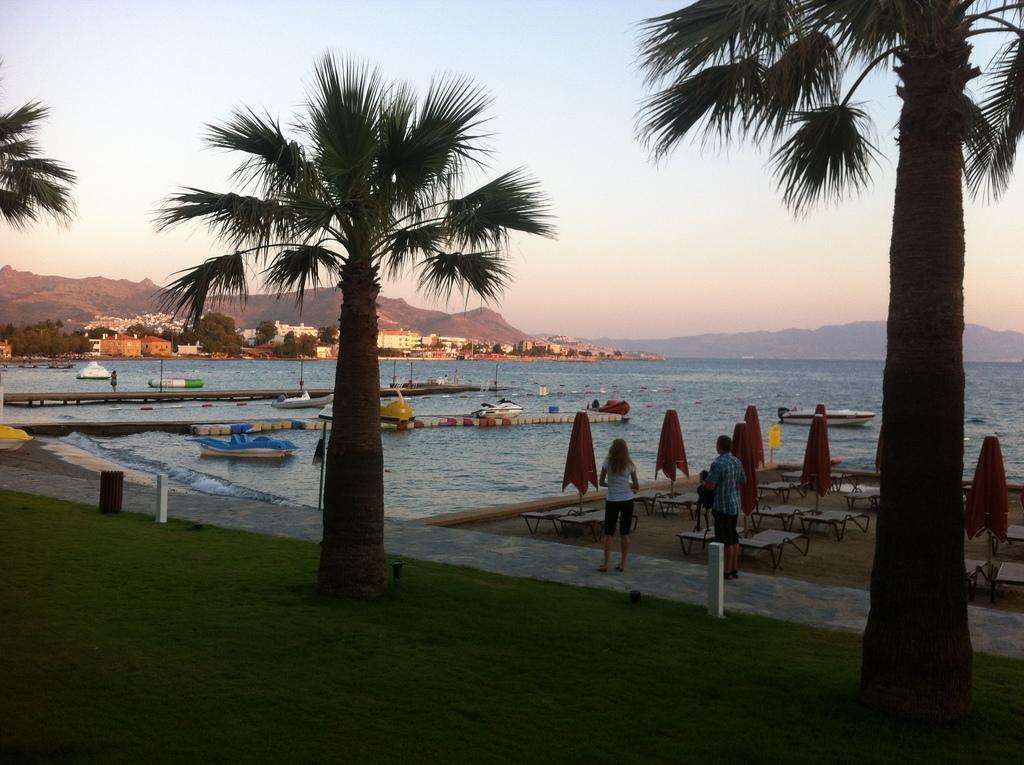Could you give a brief overview of what you see in this image? At the bottom of the image I can see the grass and few trees. In the background there is a sea. On the right side, I can see few people are standing on the road. There are some empty tables are placed on the ground. On the left side, I can see few boats on the water. In the background there are many buildings and trees and also I can see the hills. At the top I can see the sky. 